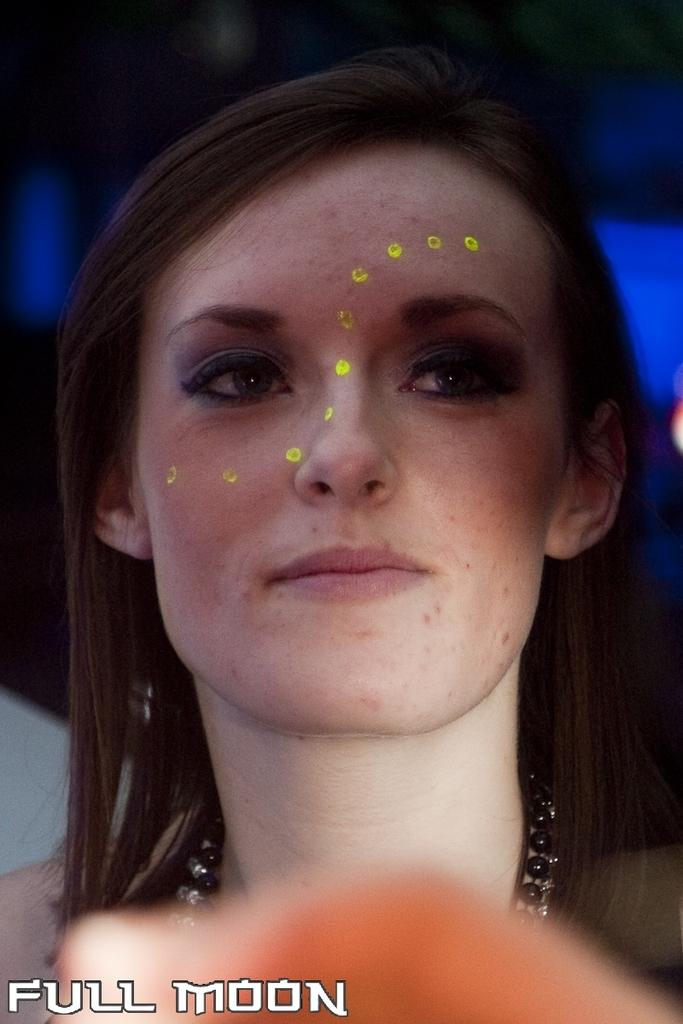Who is the main subject in the image? There is a woman in the image. What is the title of the book the woman is reading in the image? There is no book present in the image, so it is not possible to determine the title. 